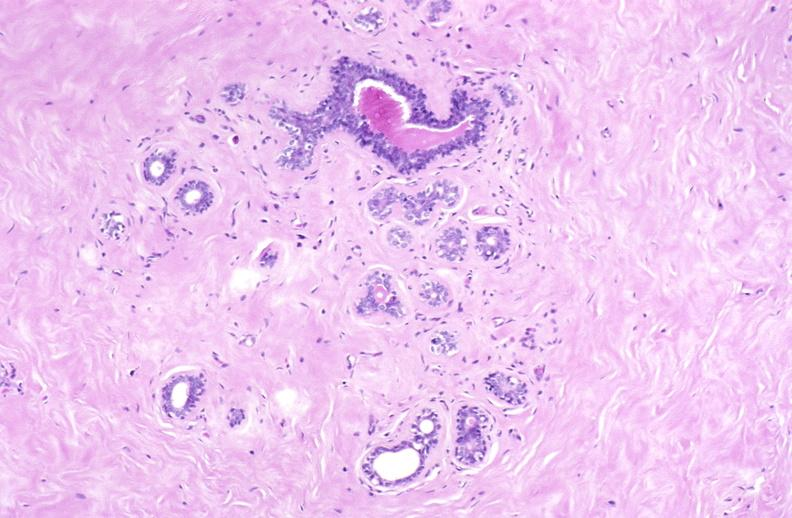does case of peritonitis slide show breast, fibroadenoma?
Answer the question using a single word or phrase. No 